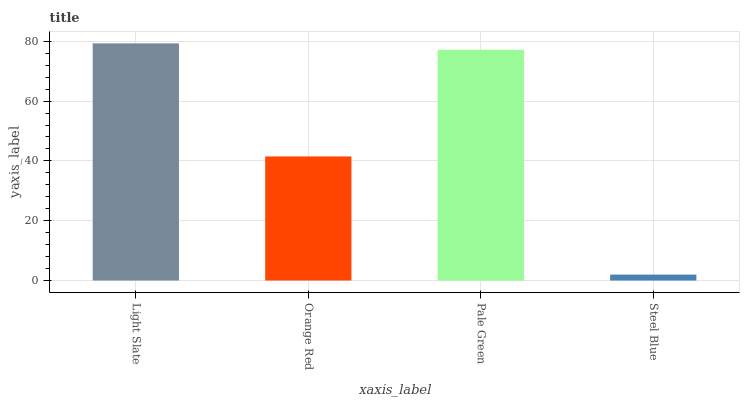Is Steel Blue the minimum?
Answer yes or no. Yes. Is Light Slate the maximum?
Answer yes or no. Yes. Is Orange Red the minimum?
Answer yes or no. No. Is Orange Red the maximum?
Answer yes or no. No. Is Light Slate greater than Orange Red?
Answer yes or no. Yes. Is Orange Red less than Light Slate?
Answer yes or no. Yes. Is Orange Red greater than Light Slate?
Answer yes or no. No. Is Light Slate less than Orange Red?
Answer yes or no. No. Is Pale Green the high median?
Answer yes or no. Yes. Is Orange Red the low median?
Answer yes or no. Yes. Is Orange Red the high median?
Answer yes or no. No. Is Light Slate the low median?
Answer yes or no. No. 